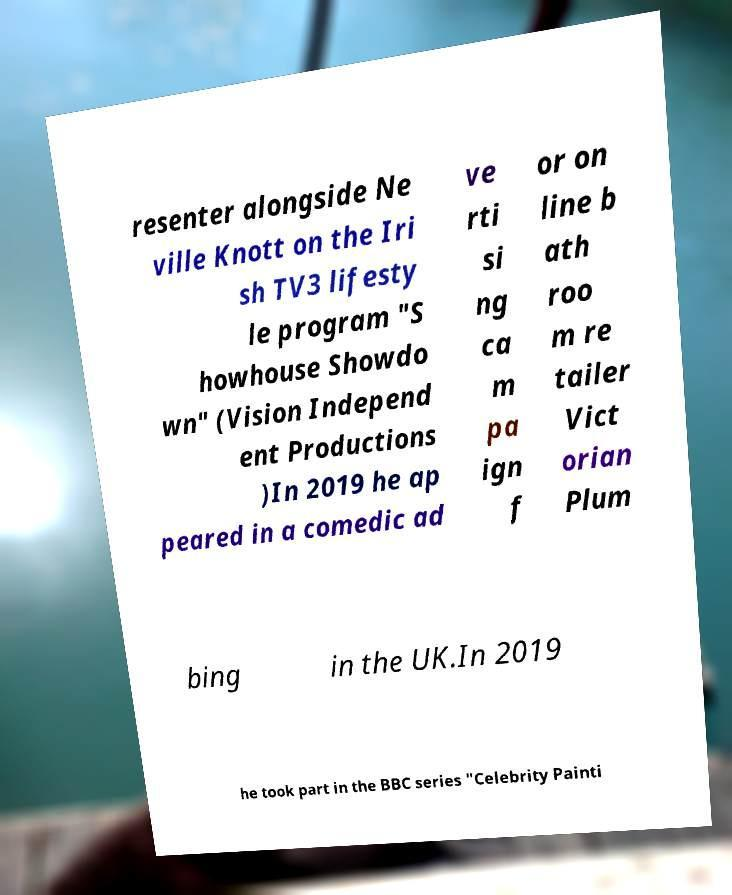Could you assist in decoding the text presented in this image and type it out clearly? resenter alongside Ne ville Knott on the Iri sh TV3 lifesty le program "S howhouse Showdo wn" (Vision Independ ent Productions )In 2019 he ap peared in a comedic ad ve rti si ng ca m pa ign f or on line b ath roo m re tailer Vict orian Plum bing in the UK.In 2019 he took part in the BBC series "Celebrity Painti 